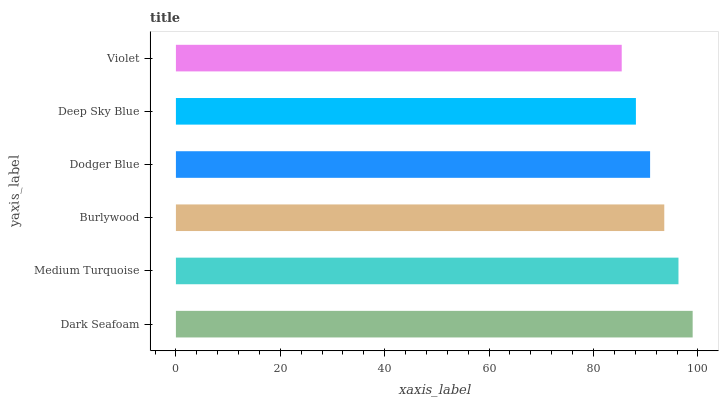Is Violet the minimum?
Answer yes or no. Yes. Is Dark Seafoam the maximum?
Answer yes or no. Yes. Is Medium Turquoise the minimum?
Answer yes or no. No. Is Medium Turquoise the maximum?
Answer yes or no. No. Is Dark Seafoam greater than Medium Turquoise?
Answer yes or no. Yes. Is Medium Turquoise less than Dark Seafoam?
Answer yes or no. Yes. Is Medium Turquoise greater than Dark Seafoam?
Answer yes or no. No. Is Dark Seafoam less than Medium Turquoise?
Answer yes or no. No. Is Burlywood the high median?
Answer yes or no. Yes. Is Dodger Blue the low median?
Answer yes or no. Yes. Is Deep Sky Blue the high median?
Answer yes or no. No. Is Deep Sky Blue the low median?
Answer yes or no. No. 